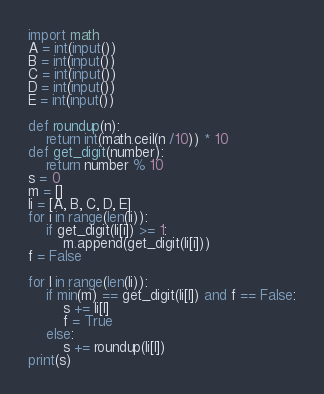Convert code to text. <code><loc_0><loc_0><loc_500><loc_500><_Python_>import math
A = int(input())
B = int(input())
C = int(input())
D = int(input())
E = int(input())

def roundup(n):
    return int(math.ceil(n /10)) * 10
def get_digit(number):
    return number % 10   
s = 0
m = []
li = [A, B, C, D, E]
for i in range(len(li)):
    if get_digit(li[i]) >= 1:
        m.append(get_digit(li[i]))
f = False
        
for l in range(len(li)):
    if min(m) == get_digit(li[l]) and f == False:
        s += li[l]
        f = True
    else:
        s += roundup(li[l])
print(s)</code> 